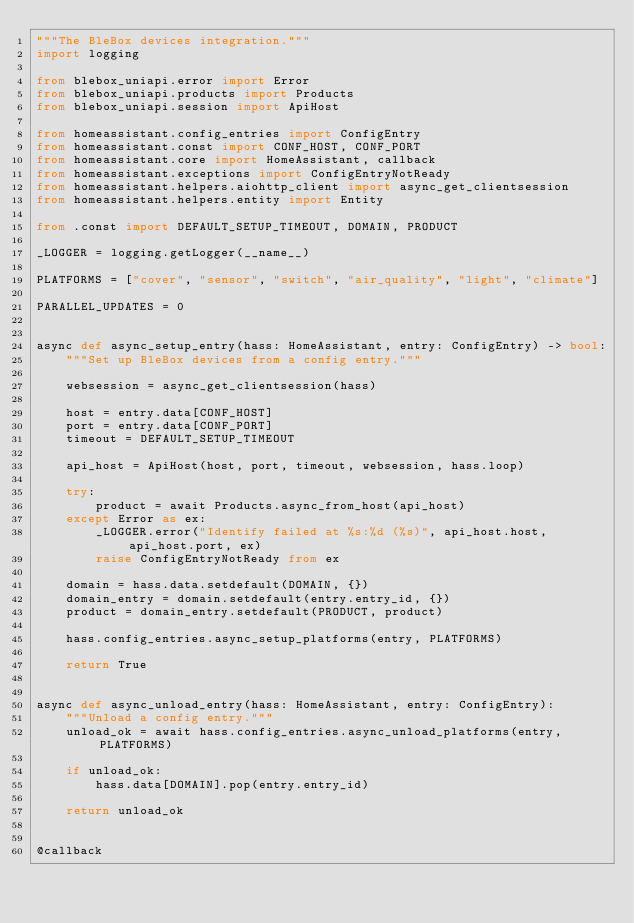Convert code to text. <code><loc_0><loc_0><loc_500><loc_500><_Python_>"""The BleBox devices integration."""
import logging

from blebox_uniapi.error import Error
from blebox_uniapi.products import Products
from blebox_uniapi.session import ApiHost

from homeassistant.config_entries import ConfigEntry
from homeassistant.const import CONF_HOST, CONF_PORT
from homeassistant.core import HomeAssistant, callback
from homeassistant.exceptions import ConfigEntryNotReady
from homeassistant.helpers.aiohttp_client import async_get_clientsession
from homeassistant.helpers.entity import Entity

from .const import DEFAULT_SETUP_TIMEOUT, DOMAIN, PRODUCT

_LOGGER = logging.getLogger(__name__)

PLATFORMS = ["cover", "sensor", "switch", "air_quality", "light", "climate"]

PARALLEL_UPDATES = 0


async def async_setup_entry(hass: HomeAssistant, entry: ConfigEntry) -> bool:
    """Set up BleBox devices from a config entry."""

    websession = async_get_clientsession(hass)

    host = entry.data[CONF_HOST]
    port = entry.data[CONF_PORT]
    timeout = DEFAULT_SETUP_TIMEOUT

    api_host = ApiHost(host, port, timeout, websession, hass.loop)

    try:
        product = await Products.async_from_host(api_host)
    except Error as ex:
        _LOGGER.error("Identify failed at %s:%d (%s)", api_host.host, api_host.port, ex)
        raise ConfigEntryNotReady from ex

    domain = hass.data.setdefault(DOMAIN, {})
    domain_entry = domain.setdefault(entry.entry_id, {})
    product = domain_entry.setdefault(PRODUCT, product)

    hass.config_entries.async_setup_platforms(entry, PLATFORMS)

    return True


async def async_unload_entry(hass: HomeAssistant, entry: ConfigEntry):
    """Unload a config entry."""
    unload_ok = await hass.config_entries.async_unload_platforms(entry, PLATFORMS)

    if unload_ok:
        hass.data[DOMAIN].pop(entry.entry_id)

    return unload_ok


@callback</code> 